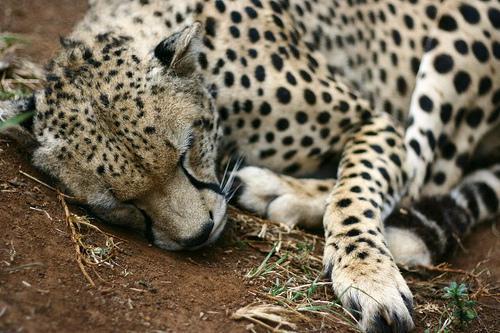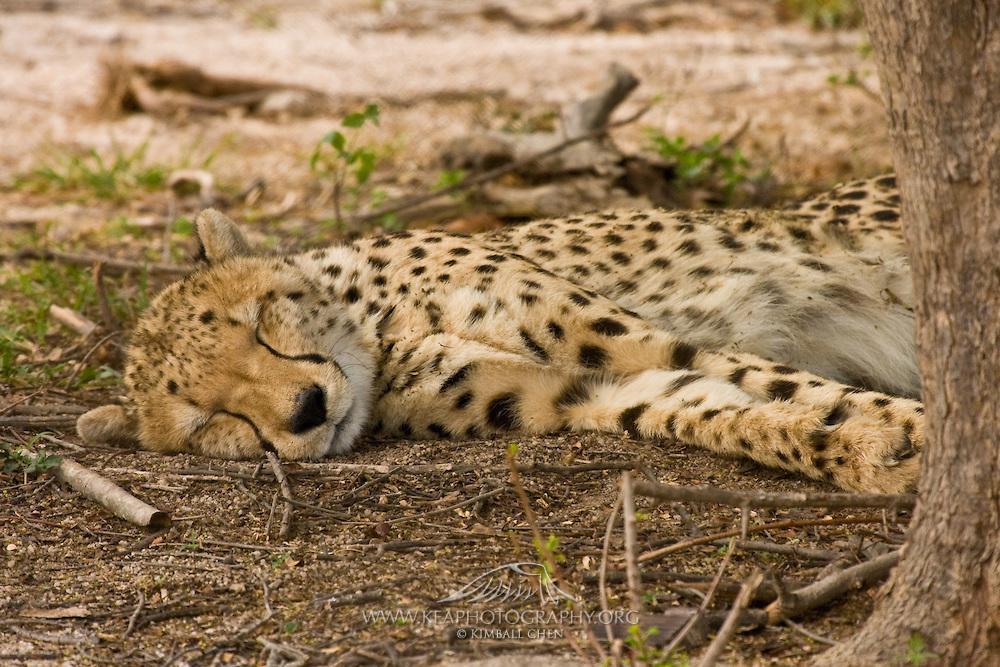The first image is the image on the left, the second image is the image on the right. Given the left and right images, does the statement "At least one animal is sleeping in a tree." hold true? Answer yes or no. No. 